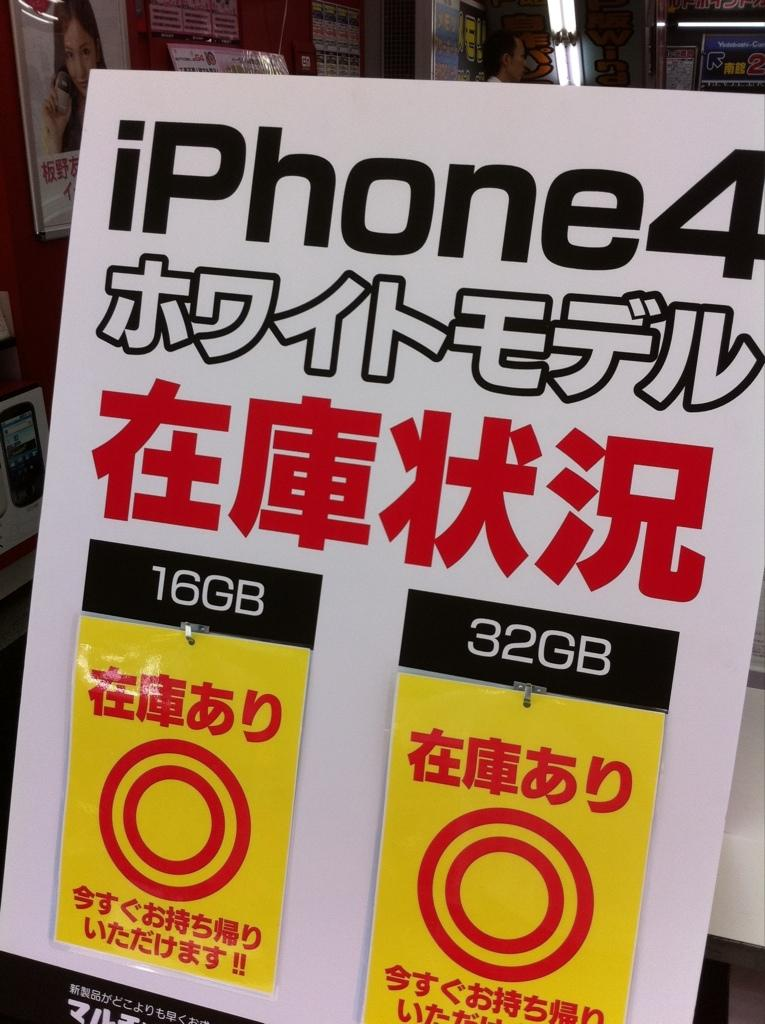<image>
Relay a brief, clear account of the picture shown. A poster advertisement for the iphone 4 in written English and Chinese. 